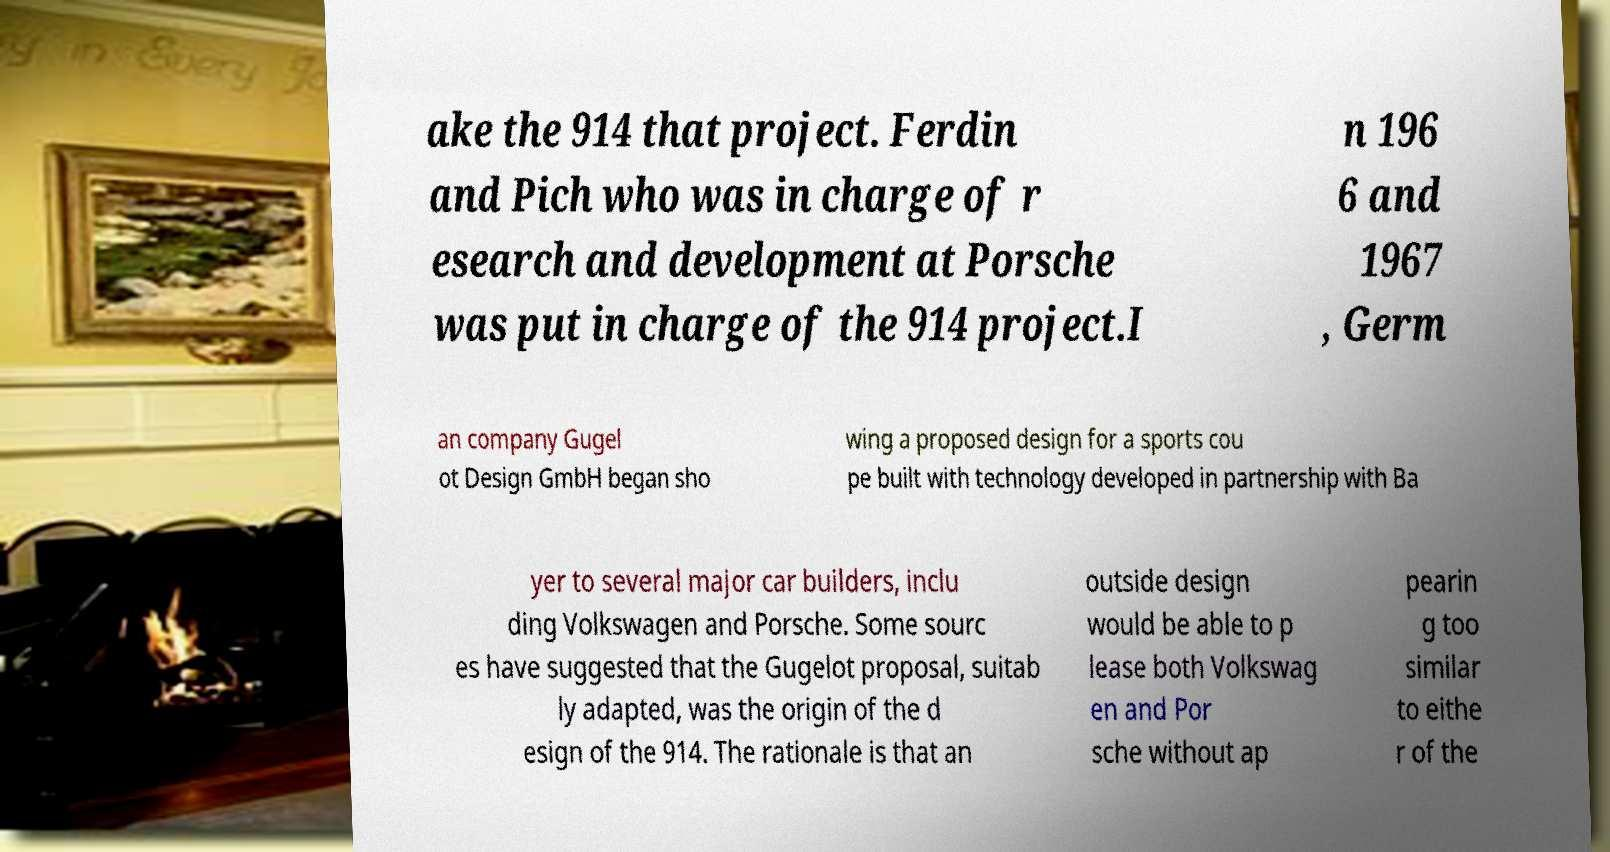What messages or text are displayed in this image? I need them in a readable, typed format. ake the 914 that project. Ferdin and Pich who was in charge of r esearch and development at Porsche was put in charge of the 914 project.I n 196 6 and 1967 , Germ an company Gugel ot Design GmbH began sho wing a proposed design for a sports cou pe built with technology developed in partnership with Ba yer to several major car builders, inclu ding Volkswagen and Porsche. Some sourc es have suggested that the Gugelot proposal, suitab ly adapted, was the origin of the d esign of the 914. The rationale is that an outside design would be able to p lease both Volkswag en and Por sche without ap pearin g too similar to eithe r of the 